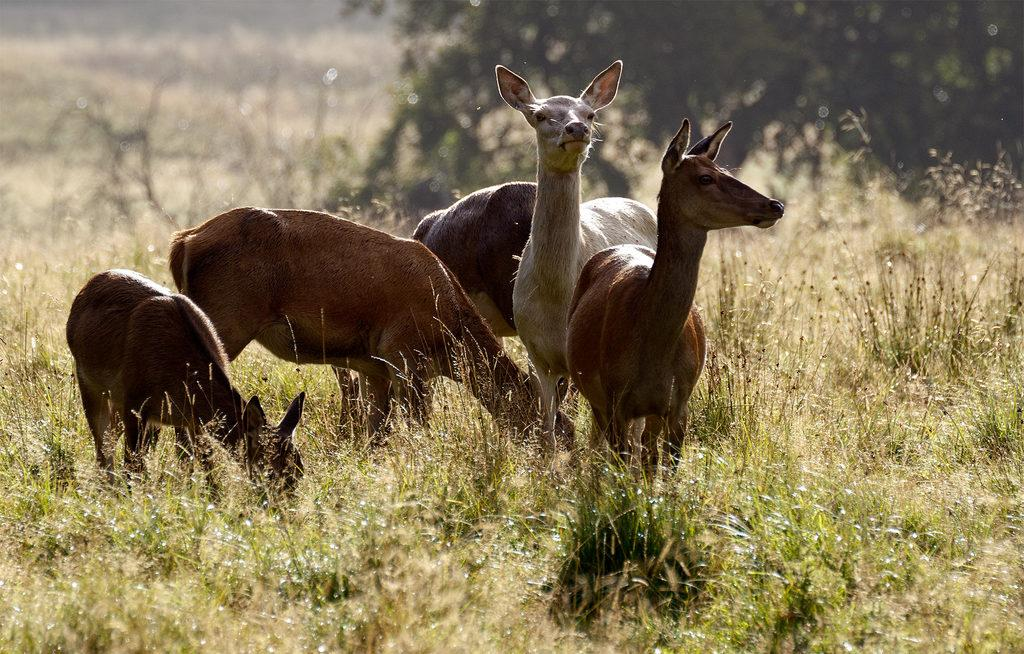How many deer are in the image? There are five deer in the image. Where are the deer located? The deer are present in the grass. What other natural element can be seen in the image? There is a tree visible in the image. What type of feather can be seen on the deer in the image? There are no feathers present on the deer in the image; they are mammals with fur. 